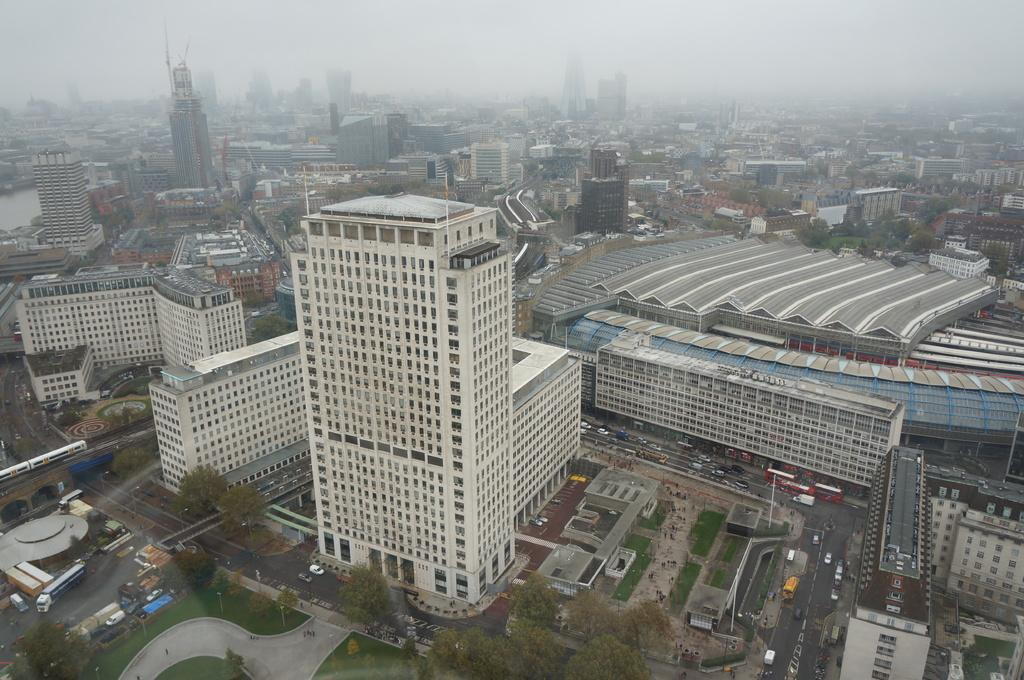What type of structures can be seen in the image? There are buildings in the image. What natural elements are present in the image? There are trees in the image. What are the vertical objects in the image? There are poles in the image. What type of transportation is visible in the image? There are vehicles on the road in the image. What can be seen in the background of the image? The sky is visible in the background of the image. What is the reaction of the wrist to the chance encounter in the image? There is no wrist or chance encounter present in the image. What type of chance event is happening in the image? There is no chance event happening in the image; it features buildings, trees, poles, vehicles, and the sky. 